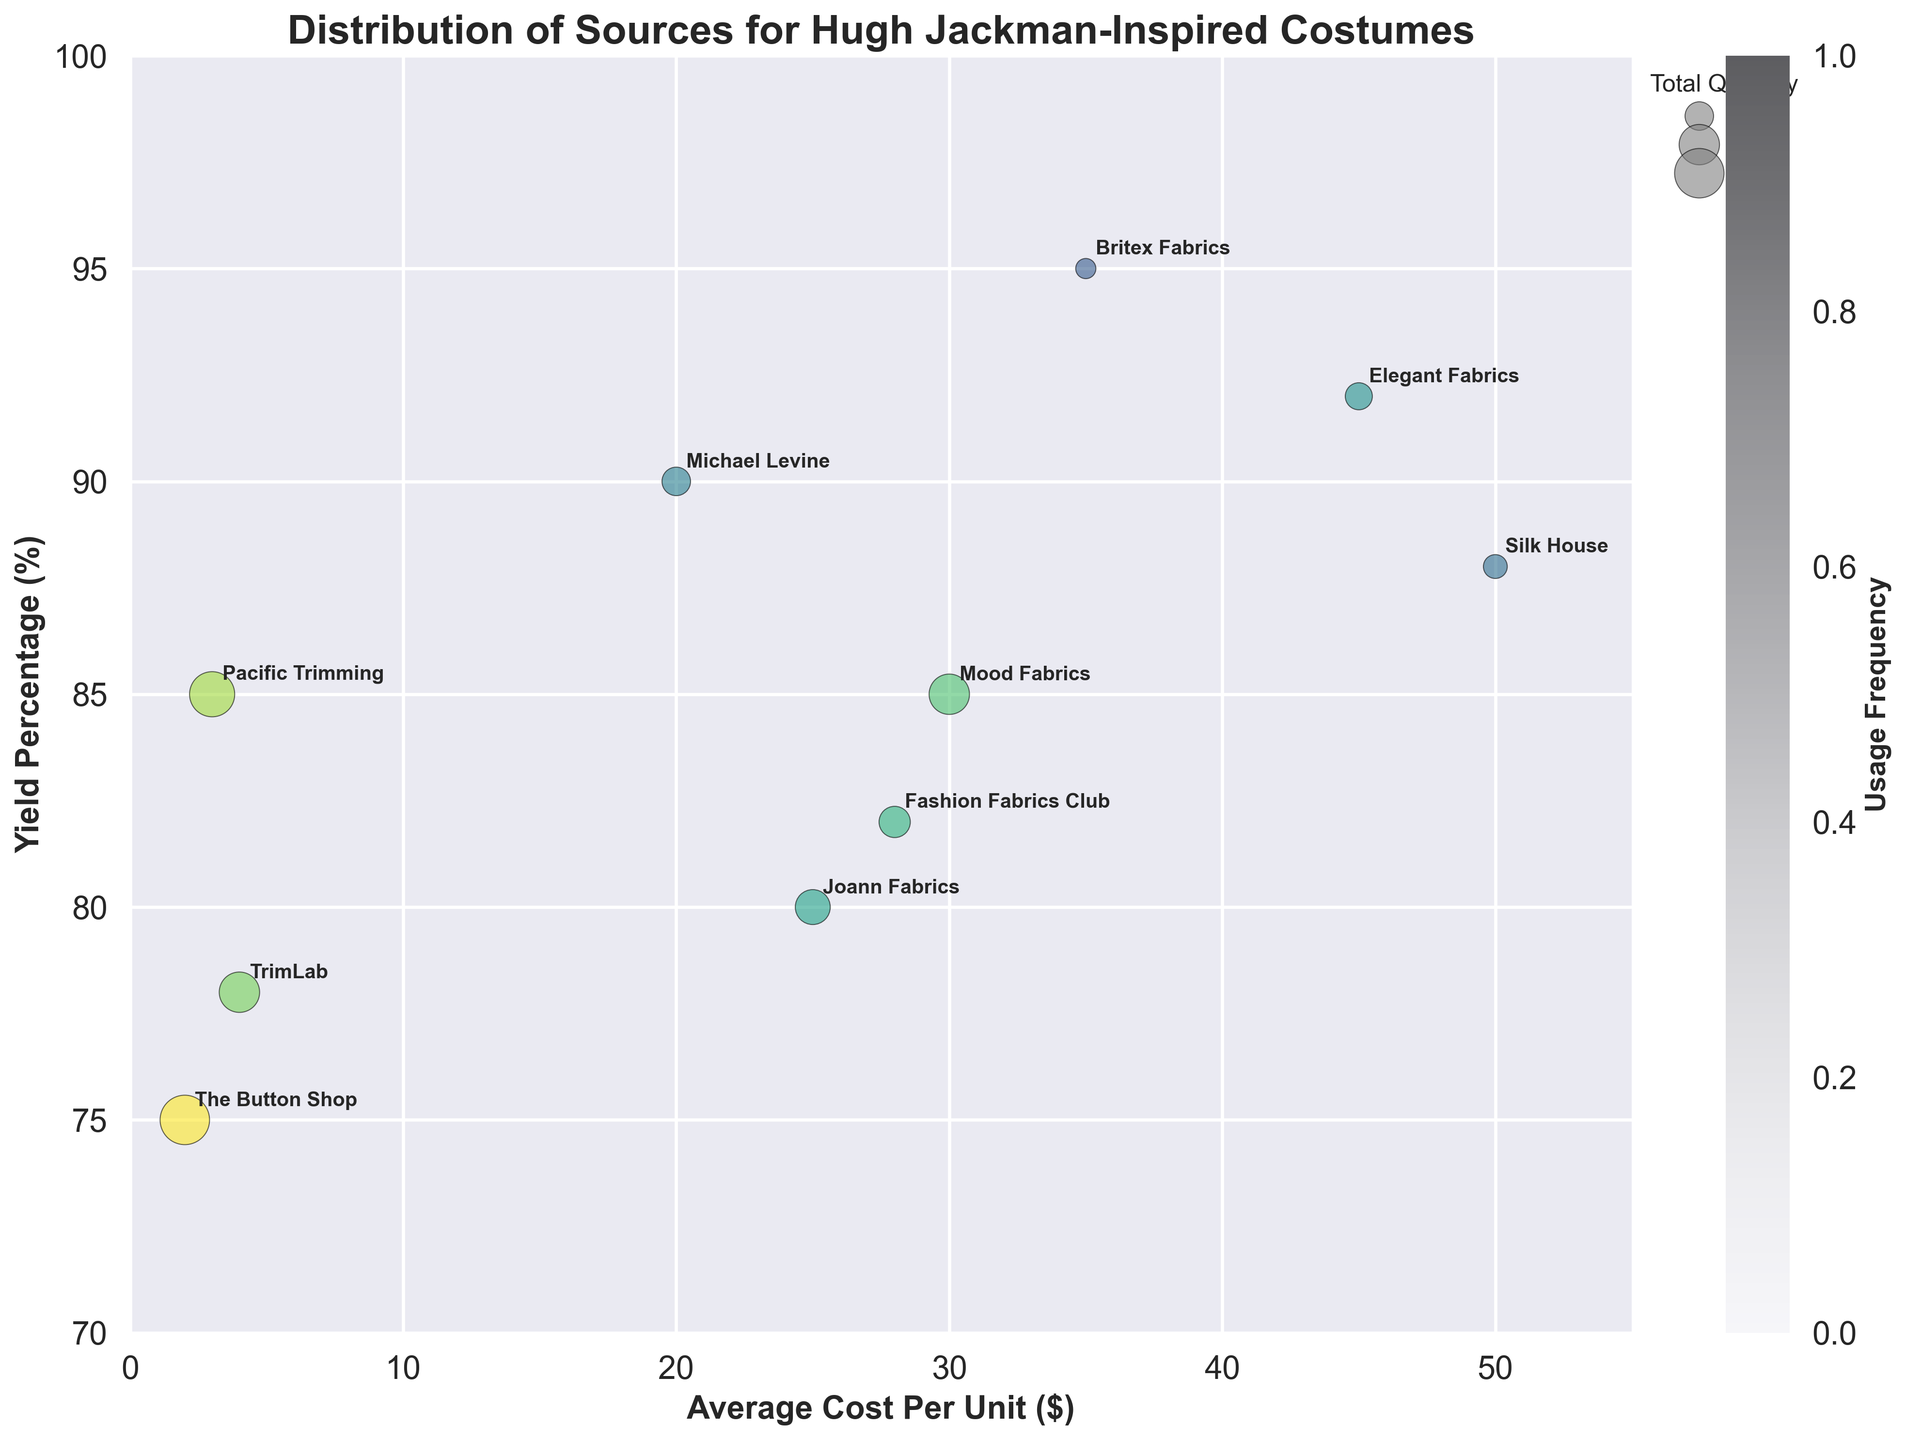What is the title of the bubble chart? The title of a chart is generally written at the top. Here, it reads "Distribution of Sources for Hugh Jackman-Inspired Costumes."
Answer: Distribution of Sources for Hugh Jackman-Inspired Costumes Which source has the highest yield percentage? By examining the y-axis (Yield Percentage) and locating the highest bubble, Britex Fabrics stands at 95%.
Answer: Britex Fabrics What is the average cost per unit of the sources plotted on the x-axis? The average cost per unit can be calculated by summing all the values on the x-axis and dividing by the number of sources. The costs are 30, 25, 20, 35, 2, 3, 4, 50, 45, 28. The sum is 242, and there are 10 sources, so the average is 242/10 = 24.2.
Answer: 24.2 Which source has the highest usage frequency? The usage frequency is represented by color intensity. The most intense colored bubble for highest usage frequency is The Button Shop with 70.
Answer: The Button Shop Compare the yield percentage of Joann Fabrics and Pacific Trimming. Which one is higher? Locate Joann Fabrics and Pacific Trimming on the chart. Joann Fabrics has a yield percentage of 80% while Pacific Trimming has 85%, making Pacific Trimming higher.
Answer: Pacific Trimming Which source has the largest bubble size, and what does it signify? The largest bubble represents the highest total quantity. The Button Shop has the biggest bubble, signifying it has the highest total quantity of 300.
Answer: The Button Shop Which source is the most cost-efficient in terms of average cost per unit and yield percentage? Cost efficiency can be assessed by examining low average cost per unit and high yield percentage. The Button Shop has the lowest cost per unit ($2) but a lower yield percentage (75%). Michael Levine has a low cost per unit ($20) and high yield percentage (90%).
Answer: Michael Levine Between Silk House and Elegant Fabrics, which source is more frequently used? Frequency use is represented by color intensity. Comparing Silk House (25) and Elegant Fabrics (35), Elegant Fabrics is more used.
Answer: Elegant Fabrics What trend can be observed in the relationship between average cost per unit and yield percentage? The trend can be observed by noting the position of bubbles relative to the axes. Generally, higher costs per unit do not necessarily correlate with higher yield percentages, though some like Britex Fabrics and Elegant Fabrics are both high in cost and yield.
Answer: No clear correlation How do Mood Fabrics and Joann Fabrics compare in terms of total quantity and yield percentage? Mood Fabrics has a higher total quantity (200) compared to Joann Fabrics (150). Their yield percentages are 85% and 80% respectively, so Mood Fabrics is higher in both aspects.
Answer: Mood Fabrics 